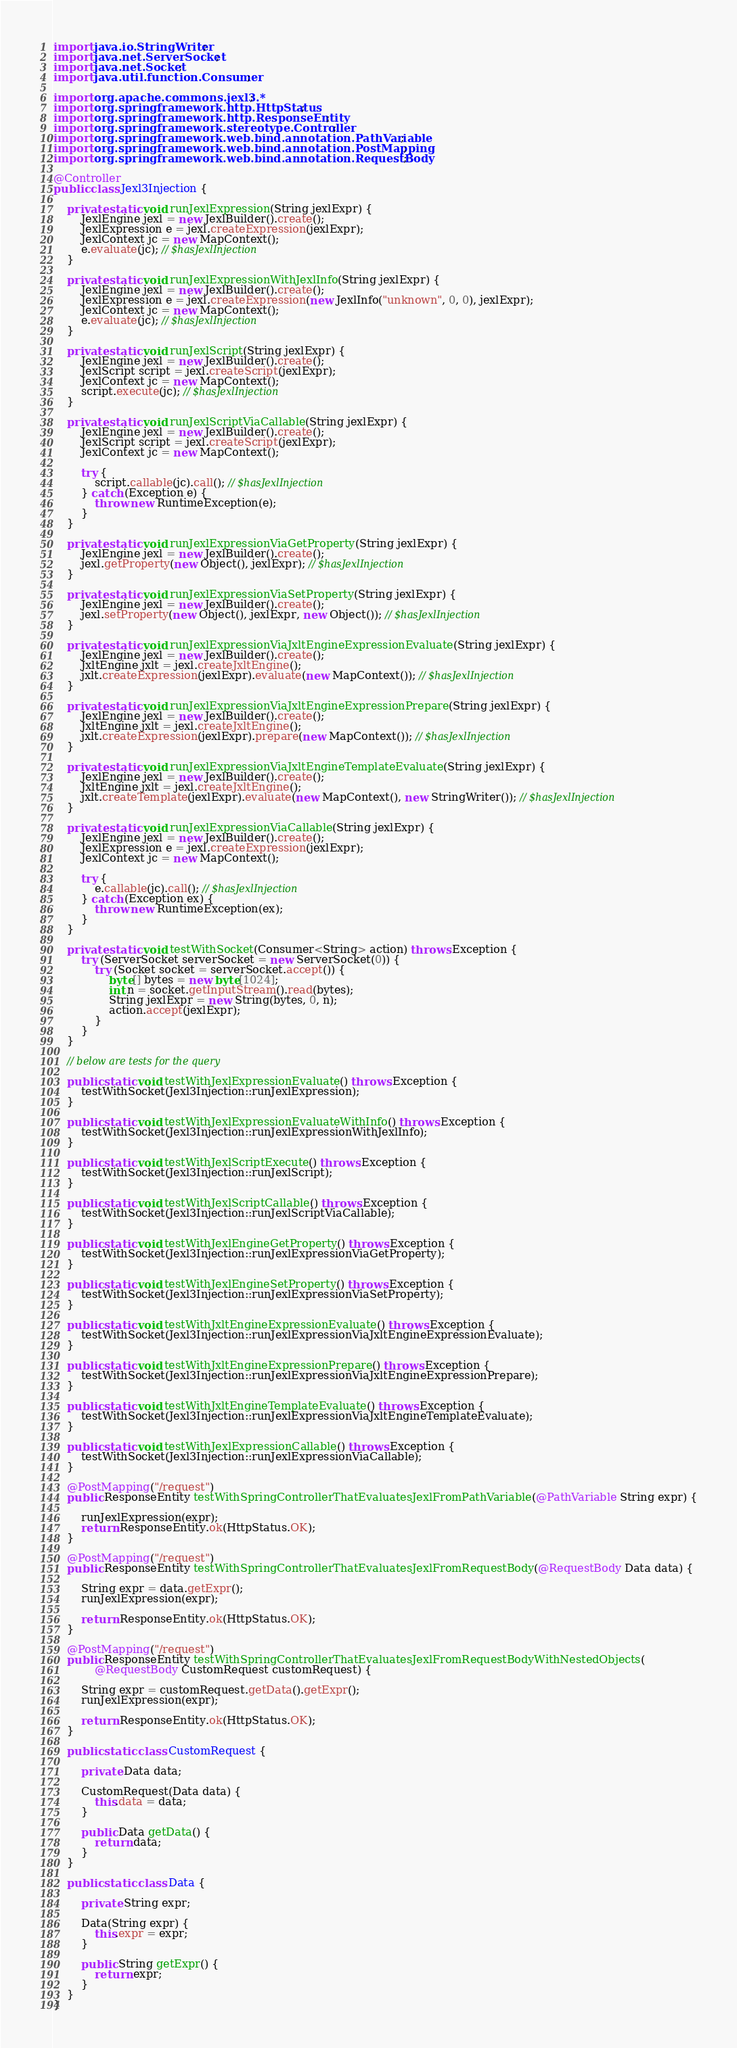Convert code to text. <code><loc_0><loc_0><loc_500><loc_500><_Java_>import java.io.StringWriter;
import java.net.ServerSocket;
import java.net.Socket;
import java.util.function.Consumer;

import org.apache.commons.jexl3.*;
import org.springframework.http.HttpStatus;
import org.springframework.http.ResponseEntity;
import org.springframework.stereotype.Controller;
import org.springframework.web.bind.annotation.PathVariable;
import org.springframework.web.bind.annotation.PostMapping;
import org.springframework.web.bind.annotation.RequestBody;

@Controller
public class Jexl3Injection {

    private static void runJexlExpression(String jexlExpr) {
        JexlEngine jexl = new JexlBuilder().create();
        JexlExpression e = jexl.createExpression(jexlExpr);
        JexlContext jc = new MapContext();
        e.evaluate(jc); // $hasJexlInjection
    }

    private static void runJexlExpressionWithJexlInfo(String jexlExpr) {
        JexlEngine jexl = new JexlBuilder().create();
        JexlExpression e = jexl.createExpression(new JexlInfo("unknown", 0, 0), jexlExpr);
        JexlContext jc = new MapContext();
        e.evaluate(jc); // $hasJexlInjection
    }

    private static void runJexlScript(String jexlExpr) {
        JexlEngine jexl = new JexlBuilder().create();
        JexlScript script = jexl.createScript(jexlExpr);
        JexlContext jc = new MapContext();
        script.execute(jc); // $hasJexlInjection
    }

    private static void runJexlScriptViaCallable(String jexlExpr) {
        JexlEngine jexl = new JexlBuilder().create();
        JexlScript script = jexl.createScript(jexlExpr);
        JexlContext jc = new MapContext();

        try {
            script.callable(jc).call(); // $hasJexlInjection
        } catch (Exception e) {
            throw new RuntimeException(e);
        }
    }

    private static void runJexlExpressionViaGetProperty(String jexlExpr) {
        JexlEngine jexl = new JexlBuilder().create();
        jexl.getProperty(new Object(), jexlExpr); // $hasJexlInjection
    }

    private static void runJexlExpressionViaSetProperty(String jexlExpr) {
        JexlEngine jexl = new JexlBuilder().create();
        jexl.setProperty(new Object(), jexlExpr, new Object()); // $hasJexlInjection
    }

    private static void runJexlExpressionViaJxltEngineExpressionEvaluate(String jexlExpr) {
        JexlEngine jexl = new JexlBuilder().create();
        JxltEngine jxlt = jexl.createJxltEngine();
        jxlt.createExpression(jexlExpr).evaluate(new MapContext()); // $hasJexlInjection
    }

    private static void runJexlExpressionViaJxltEngineExpressionPrepare(String jexlExpr) {
        JexlEngine jexl = new JexlBuilder().create();
        JxltEngine jxlt = jexl.createJxltEngine();
        jxlt.createExpression(jexlExpr).prepare(new MapContext()); // $hasJexlInjection
    }

    private static void runJexlExpressionViaJxltEngineTemplateEvaluate(String jexlExpr) {
        JexlEngine jexl = new JexlBuilder().create();
        JxltEngine jxlt = jexl.createJxltEngine();
        jxlt.createTemplate(jexlExpr).evaluate(new MapContext(), new StringWriter()); // $hasJexlInjection
    }

    private static void runJexlExpressionViaCallable(String jexlExpr) {
        JexlEngine jexl = new JexlBuilder().create();
        JexlExpression e = jexl.createExpression(jexlExpr);
        JexlContext jc = new MapContext();

        try {
            e.callable(jc).call(); // $hasJexlInjection
        } catch (Exception ex) {
            throw new RuntimeException(ex);
        }
    }

    private static void testWithSocket(Consumer<String> action) throws Exception {
        try (ServerSocket serverSocket = new ServerSocket(0)) {
            try (Socket socket = serverSocket.accept()) {
                byte[] bytes = new byte[1024];
                int n = socket.getInputStream().read(bytes);
                String jexlExpr = new String(bytes, 0, n);
                action.accept(jexlExpr);
            }
        }
    }

    // below are tests for the query

    public static void testWithJexlExpressionEvaluate() throws Exception {
        testWithSocket(Jexl3Injection::runJexlExpression);
    }

    public static void testWithJexlExpressionEvaluateWithInfo() throws Exception {
        testWithSocket(Jexl3Injection::runJexlExpressionWithJexlInfo);
    }

    public static void testWithJexlScriptExecute() throws Exception {
        testWithSocket(Jexl3Injection::runJexlScript);
    }

    public static void testWithJexlScriptCallable() throws Exception {
        testWithSocket(Jexl3Injection::runJexlScriptViaCallable);
    }

    public static void testWithJexlEngineGetProperty() throws Exception {
        testWithSocket(Jexl3Injection::runJexlExpressionViaGetProperty);
    }

    public static void testWithJexlEngineSetProperty() throws Exception {
        testWithSocket(Jexl3Injection::runJexlExpressionViaSetProperty);
    }

    public static void testWithJxltEngineExpressionEvaluate() throws Exception {
        testWithSocket(Jexl3Injection::runJexlExpressionViaJxltEngineExpressionEvaluate);
    }

    public static void testWithJxltEngineExpressionPrepare() throws Exception {
        testWithSocket(Jexl3Injection::runJexlExpressionViaJxltEngineExpressionPrepare);
    }

    public static void testWithJxltEngineTemplateEvaluate() throws Exception {
        testWithSocket(Jexl3Injection::runJexlExpressionViaJxltEngineTemplateEvaluate);
    }

    public static void testWithJexlExpressionCallable() throws Exception {
        testWithSocket(Jexl3Injection::runJexlExpressionViaCallable);
    }

    @PostMapping("/request")
    public ResponseEntity testWithSpringControllerThatEvaluatesJexlFromPathVariable(@PathVariable String expr) {

        runJexlExpression(expr);
        return ResponseEntity.ok(HttpStatus.OK);
    }

    @PostMapping("/request")
    public ResponseEntity testWithSpringControllerThatEvaluatesJexlFromRequestBody(@RequestBody Data data) {

        String expr = data.getExpr();
        runJexlExpression(expr);

        return ResponseEntity.ok(HttpStatus.OK);
    }

    @PostMapping("/request")
    public ResponseEntity testWithSpringControllerThatEvaluatesJexlFromRequestBodyWithNestedObjects(
            @RequestBody CustomRequest customRequest) {

        String expr = customRequest.getData().getExpr();
        runJexlExpression(expr);

        return ResponseEntity.ok(HttpStatus.OK);
    }

    public static class CustomRequest {

        private Data data;

        CustomRequest(Data data) {
            this.data = data;
        }

        public Data getData() {
            return data;
        }
    }

    public static class Data {

        private String expr;

        Data(String expr) {
            this.expr = expr;
        }

        public String getExpr() {
            return expr;
        }
    }
}
</code> 